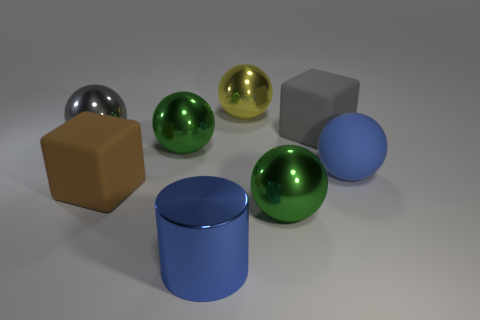There is a ball on the right side of the matte cube that is behind the big rubber ball; what is its material?
Provide a short and direct response. Rubber. There is a yellow object that is the same size as the gray ball; what is its material?
Provide a succinct answer. Metal. Is the size of the rubber block that is in front of the gray matte block the same as the cylinder?
Ensure brevity in your answer.  Yes. Do the large blue object left of the gray cube and the brown matte thing have the same shape?
Give a very brief answer. No. How many objects are either green metal objects or large cubes right of the large brown matte block?
Your response must be concise. 3. Are there fewer gray objects than tiny brown metallic cubes?
Provide a short and direct response. No. Are there more rubber cylinders than gray blocks?
Keep it short and to the point. No. How many other things are there of the same material as the large blue ball?
Give a very brief answer. 2. How many large gray matte cubes are left of the ball behind the big rubber cube behind the large brown object?
Offer a terse response. 0. What number of shiny objects are balls or large green things?
Your answer should be compact. 4. 